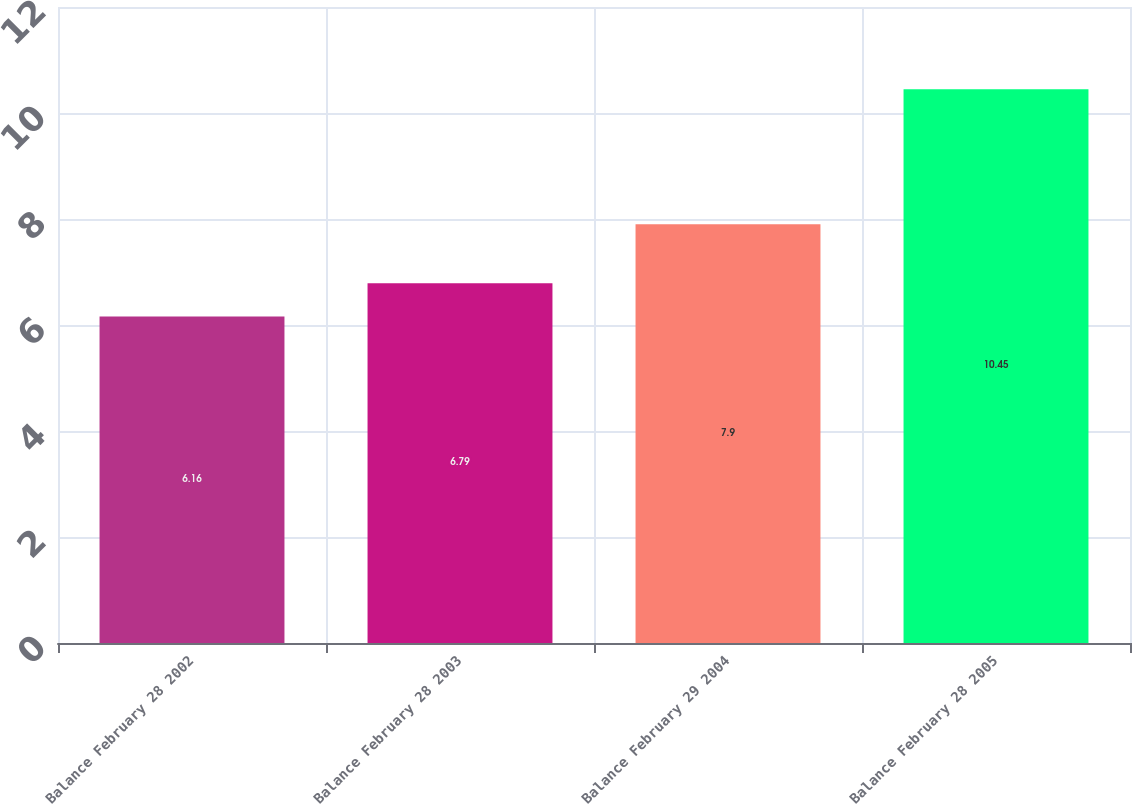Convert chart. <chart><loc_0><loc_0><loc_500><loc_500><bar_chart><fcel>Balance February 28 2002<fcel>Balance February 28 2003<fcel>Balance February 29 2004<fcel>Balance February 28 2005<nl><fcel>6.16<fcel>6.79<fcel>7.9<fcel>10.45<nl></chart> 